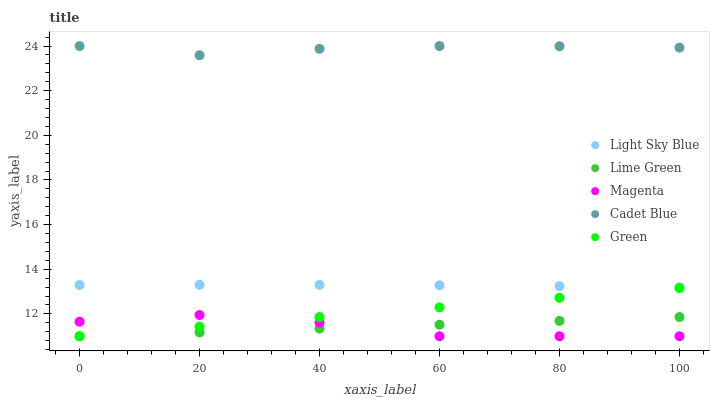Does Magenta have the minimum area under the curve?
Answer yes or no. Yes. Does Cadet Blue have the maximum area under the curve?
Answer yes or no. Yes. Does Green have the minimum area under the curve?
Answer yes or no. No. Does Green have the maximum area under the curve?
Answer yes or no. No. Is Lime Green the smoothest?
Answer yes or no. Yes. Is Magenta the roughest?
Answer yes or no. Yes. Is Green the smoothest?
Answer yes or no. No. Is Green the roughest?
Answer yes or no. No. Does Green have the lowest value?
Answer yes or no. Yes. Does Light Sky Blue have the lowest value?
Answer yes or no. No. Does Cadet Blue have the highest value?
Answer yes or no. Yes. Does Green have the highest value?
Answer yes or no. No. Is Lime Green less than Cadet Blue?
Answer yes or no. Yes. Is Cadet Blue greater than Green?
Answer yes or no. Yes. Does Green intersect Lime Green?
Answer yes or no. Yes. Is Green less than Lime Green?
Answer yes or no. No. Is Green greater than Lime Green?
Answer yes or no. No. Does Lime Green intersect Cadet Blue?
Answer yes or no. No. 